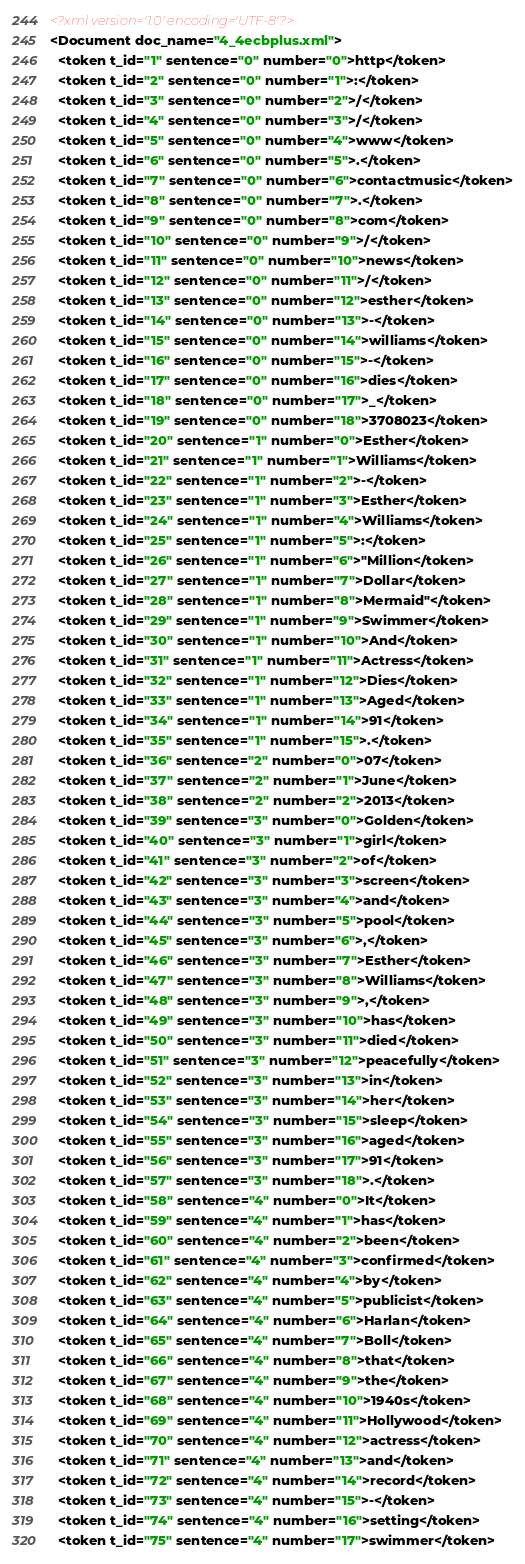Convert code to text. <code><loc_0><loc_0><loc_500><loc_500><_XML_><?xml version='1.0' encoding='UTF-8'?>
<Document doc_name="4_4ecbplus.xml">
  <token t_id="1" sentence="0" number="0">http</token>
  <token t_id="2" sentence="0" number="1">:</token>
  <token t_id="3" sentence="0" number="2">/</token>
  <token t_id="4" sentence="0" number="3">/</token>
  <token t_id="5" sentence="0" number="4">www</token>
  <token t_id="6" sentence="0" number="5">.</token>
  <token t_id="7" sentence="0" number="6">contactmusic</token>
  <token t_id="8" sentence="0" number="7">.</token>
  <token t_id="9" sentence="0" number="8">com</token>
  <token t_id="10" sentence="0" number="9">/</token>
  <token t_id="11" sentence="0" number="10">news</token>
  <token t_id="12" sentence="0" number="11">/</token>
  <token t_id="13" sentence="0" number="12">esther</token>
  <token t_id="14" sentence="0" number="13">-</token>
  <token t_id="15" sentence="0" number="14">williams</token>
  <token t_id="16" sentence="0" number="15">-</token>
  <token t_id="17" sentence="0" number="16">dies</token>
  <token t_id="18" sentence="0" number="17">_</token>
  <token t_id="19" sentence="0" number="18">3708023</token>
  <token t_id="20" sentence="1" number="0">Esther</token>
  <token t_id="21" sentence="1" number="1">Williams</token>
  <token t_id="22" sentence="1" number="2">-</token>
  <token t_id="23" sentence="1" number="3">Esther</token>
  <token t_id="24" sentence="1" number="4">Williams</token>
  <token t_id="25" sentence="1" number="5">:</token>
  <token t_id="26" sentence="1" number="6">"Million</token>
  <token t_id="27" sentence="1" number="7">Dollar</token>
  <token t_id="28" sentence="1" number="8">Mermaid"</token>
  <token t_id="29" sentence="1" number="9">Swimmer</token>
  <token t_id="30" sentence="1" number="10">And</token>
  <token t_id="31" sentence="1" number="11">Actress</token>
  <token t_id="32" sentence="1" number="12">Dies</token>
  <token t_id="33" sentence="1" number="13">Aged</token>
  <token t_id="34" sentence="1" number="14">91</token>
  <token t_id="35" sentence="1" number="15">.</token>
  <token t_id="36" sentence="2" number="0">07</token>
  <token t_id="37" sentence="2" number="1">June</token>
  <token t_id="38" sentence="2" number="2">2013</token>
  <token t_id="39" sentence="3" number="0">Golden</token>
  <token t_id="40" sentence="3" number="1">girl</token>
  <token t_id="41" sentence="3" number="2">of</token>
  <token t_id="42" sentence="3" number="3">screen</token>
  <token t_id="43" sentence="3" number="4">and</token>
  <token t_id="44" sentence="3" number="5">pool</token>
  <token t_id="45" sentence="3" number="6">,</token>
  <token t_id="46" sentence="3" number="7">Esther</token>
  <token t_id="47" sentence="3" number="8">Williams</token>
  <token t_id="48" sentence="3" number="9">,</token>
  <token t_id="49" sentence="3" number="10">has</token>
  <token t_id="50" sentence="3" number="11">died</token>
  <token t_id="51" sentence="3" number="12">peacefully</token>
  <token t_id="52" sentence="3" number="13">in</token>
  <token t_id="53" sentence="3" number="14">her</token>
  <token t_id="54" sentence="3" number="15">sleep</token>
  <token t_id="55" sentence="3" number="16">aged</token>
  <token t_id="56" sentence="3" number="17">91</token>
  <token t_id="57" sentence="3" number="18">.</token>
  <token t_id="58" sentence="4" number="0">It</token>
  <token t_id="59" sentence="4" number="1">has</token>
  <token t_id="60" sentence="4" number="2">been</token>
  <token t_id="61" sentence="4" number="3">confirmed</token>
  <token t_id="62" sentence="4" number="4">by</token>
  <token t_id="63" sentence="4" number="5">publicist</token>
  <token t_id="64" sentence="4" number="6">Harlan</token>
  <token t_id="65" sentence="4" number="7">Boll</token>
  <token t_id="66" sentence="4" number="8">that</token>
  <token t_id="67" sentence="4" number="9">the</token>
  <token t_id="68" sentence="4" number="10">1940s</token>
  <token t_id="69" sentence="4" number="11">Hollywood</token>
  <token t_id="70" sentence="4" number="12">actress</token>
  <token t_id="71" sentence="4" number="13">and</token>
  <token t_id="72" sentence="4" number="14">record</token>
  <token t_id="73" sentence="4" number="15">-</token>
  <token t_id="74" sentence="4" number="16">setting</token>
  <token t_id="75" sentence="4" number="17">swimmer</token></code> 